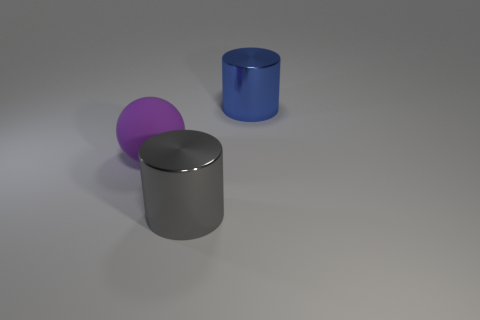Is there any other thing that is the same material as the purple sphere?
Keep it short and to the point. No. What size is the object to the right of the big cylinder on the left side of the object that is behind the matte thing?
Provide a short and direct response. Large. What number of gray objects are the same material as the large purple sphere?
Your answer should be very brief. 0. What number of purple things have the same size as the matte sphere?
Keep it short and to the point. 0. What material is the cylinder on the left side of the big metallic object behind the big gray cylinder that is on the right side of the rubber thing?
Offer a terse response. Metal. What number of things are large blue metal blocks or purple matte spheres?
Your answer should be very brief. 1. What is the shape of the big matte object?
Give a very brief answer. Sphere. The object left of the metallic object in front of the large purple ball is what shape?
Your answer should be compact. Sphere. Is the cylinder that is in front of the blue shiny cylinder made of the same material as the big blue thing?
Provide a short and direct response. Yes. What number of yellow objects are either metallic cylinders or large things?
Your answer should be very brief. 0. 